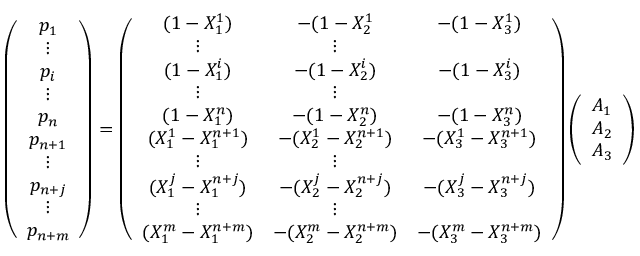Convert formula to latex. <formula><loc_0><loc_0><loc_500><loc_500>\left ( \begin{array} { c } { p _ { 1 } } \\ { \vdots } \\ { p _ { i } } \\ { \vdots } \\ { p _ { n } } \\ { p _ { n + 1 } } \\ { \vdots } \\ { p _ { n + j } } \\ { \vdots } \\ { p _ { n + m } } \end{array} \right ) = \left ( \begin{array} { c c c } { ( 1 - X _ { 1 } ^ { 1 } ) } & { - ( 1 - X _ { 2 } ^ { 1 } } & { - ( 1 - X _ { 3 } ^ { 1 } ) } \\ { \vdots } & { \vdots } \\ { ( 1 - X _ { 1 } ^ { i } ) } & { - ( 1 - X _ { 2 } ^ { i } ) } & { - ( 1 - X _ { 3 } ^ { i } ) } \\ { \vdots } & { \vdots } \\ { ( 1 - X _ { 1 } ^ { n } ) } & { - ( 1 - X _ { 2 } ^ { n } ) } & { - ( 1 - X _ { 3 } ^ { n } ) } \\ { ( X _ { 1 } ^ { 1 } - X _ { 1 } ^ { n + 1 } ) } & { - ( X _ { 2 } ^ { 1 } - X _ { 2 } ^ { n + 1 } ) } & { - ( X _ { 3 } ^ { 1 } - X _ { 3 } ^ { n + 1 } ) } \\ { \vdots } & { \vdots } \\ { ( X _ { 1 } ^ { j } - X _ { 1 } ^ { n + j } ) } & { - ( X _ { 2 } ^ { j } - X _ { 2 } ^ { n + j } ) } & { - ( X _ { 3 } ^ { j } - X _ { 3 } ^ { n + j } ) } \\ { \vdots } & { \vdots } \\ { ( X _ { 1 } ^ { m } - X _ { 1 } ^ { n + m } ) } & { - ( X _ { 2 } ^ { m } - X _ { 2 } ^ { n + m } ) } & { - ( X _ { 3 } ^ { m } - X _ { 3 } ^ { n + m } ) } \end{array} \right ) \left ( \begin{array} { c } { A _ { 1 } } \\ { A _ { 2 } } \\ { A _ { 3 } } \end{array} \right )</formula> 